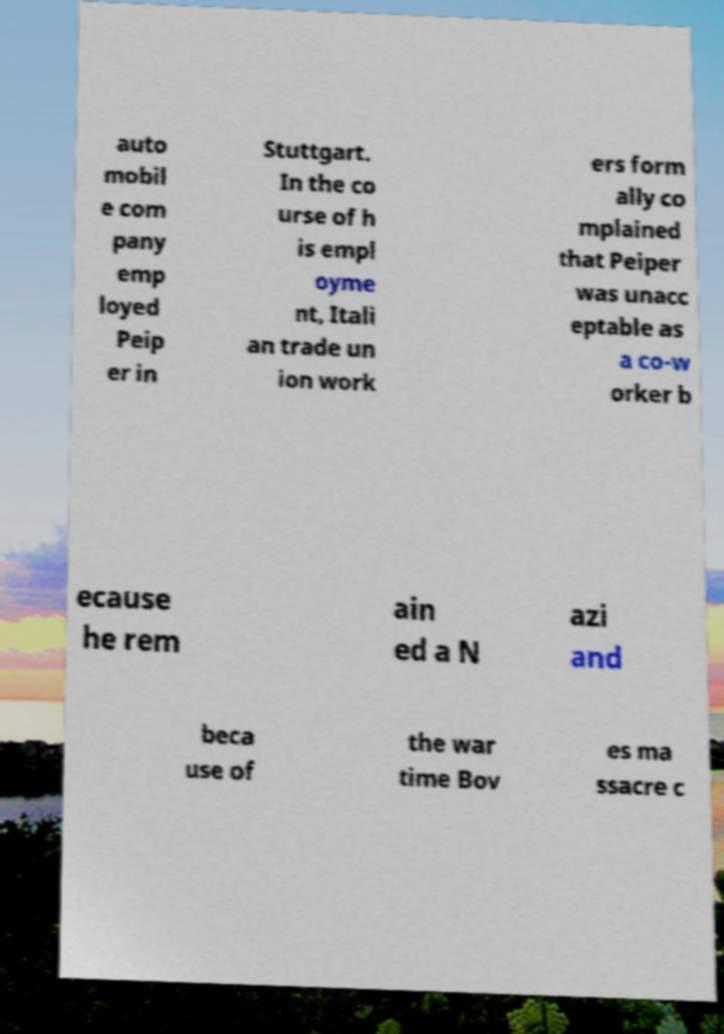What messages or text are displayed in this image? I need them in a readable, typed format. auto mobil e com pany emp loyed Peip er in Stuttgart. In the co urse of h is empl oyme nt, Itali an trade un ion work ers form ally co mplained that Peiper was unacc eptable as a co-w orker b ecause he rem ain ed a N azi and beca use of the war time Bov es ma ssacre c 